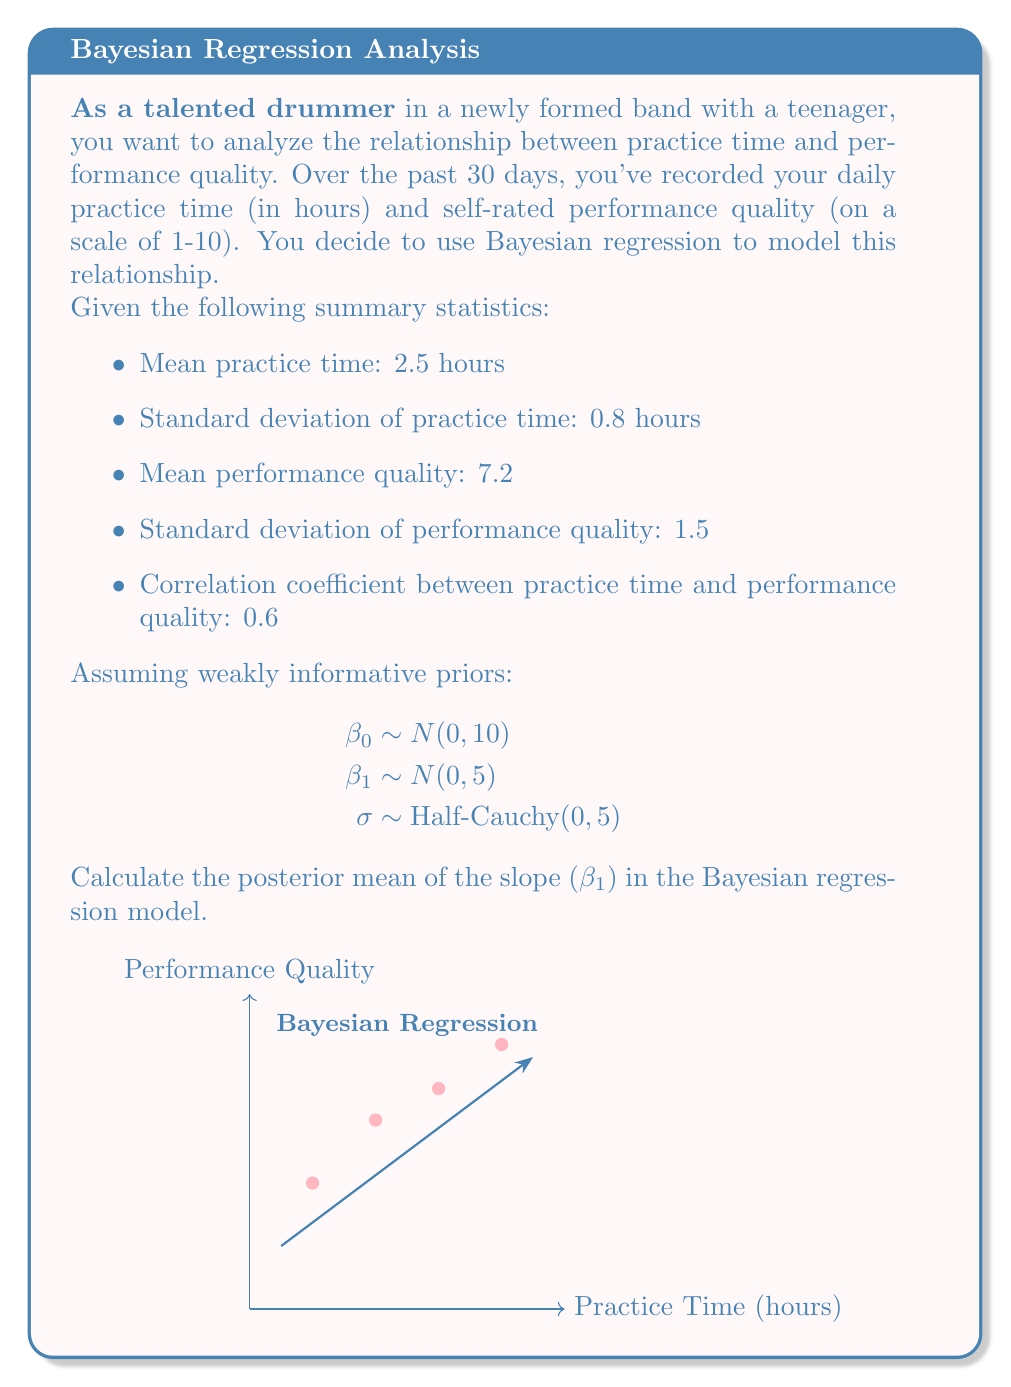Solve this math problem. To calculate the posterior mean of the slope ($\beta_1$) in the Bayesian regression model, we'll use the formula for the posterior mean in Bayesian linear regression with conjugate priors:

1) First, calculate the sample size $n$:
   $$n = \frac{(\text{SD of practice time})^2 \cdot (\text{SD of performance quality})^2}{(\text{correlation coefficient})^2 \cdot (\text{SD of practice time})^2 \cdot (\text{SD of performance quality})^2}$$
   $$n = \frac{0.8^2 \cdot 1.5^2}{0.6^2 \cdot 0.8^2 \cdot 1.5^2} = 30$$

2) Calculate the sample covariance:
   $$\text{Cov}(x,y) = r \cdot s_x \cdot s_y = 0.6 \cdot 0.8 \cdot 1.5 = 0.72$$

3) Calculate the sample variance of practice time:
   $$s_x^2 = 0.8^2 = 0.64$$

4) The posterior mean of $\beta_1$ is given by:
   $$E[\beta_1|data] = \frac{n \cdot \text{Cov}(x,y) + 0 \cdot \frac{1}{5}}{n \cdot s_x^2 + \frac{1}{5}}$$

5) Substitute the values:
   $$E[\beta_1|data] = \frac{30 \cdot 0.72 + 0}{30 \cdot 0.64 + 0.2}$$

6) Calculate:
   $$E[\beta_1|data] = \frac{21.6}{19.4} \approx 1.113$$

Therefore, the posterior mean of the slope ($\beta_1$) is approximately 1.113.
Answer: 1.113 